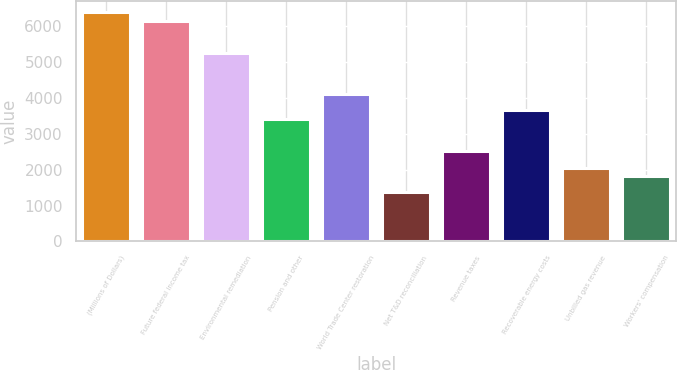Convert chart. <chart><loc_0><loc_0><loc_500><loc_500><bar_chart><fcel>(Millions of Dollars)<fcel>Future federal income tax<fcel>Environmental remediation<fcel>Pension and other<fcel>World Trade Center restoration<fcel>Net T&D reconciliation<fcel>Revenue taxes<fcel>Recoverable energy costs<fcel>Unbilled gas revenue<fcel>Workers' compensation<nl><fcel>6386.4<fcel>6158.6<fcel>5247.4<fcel>3425<fcel>4108.4<fcel>1374.8<fcel>2513.8<fcel>3652.8<fcel>2058.2<fcel>1830.4<nl></chart> 